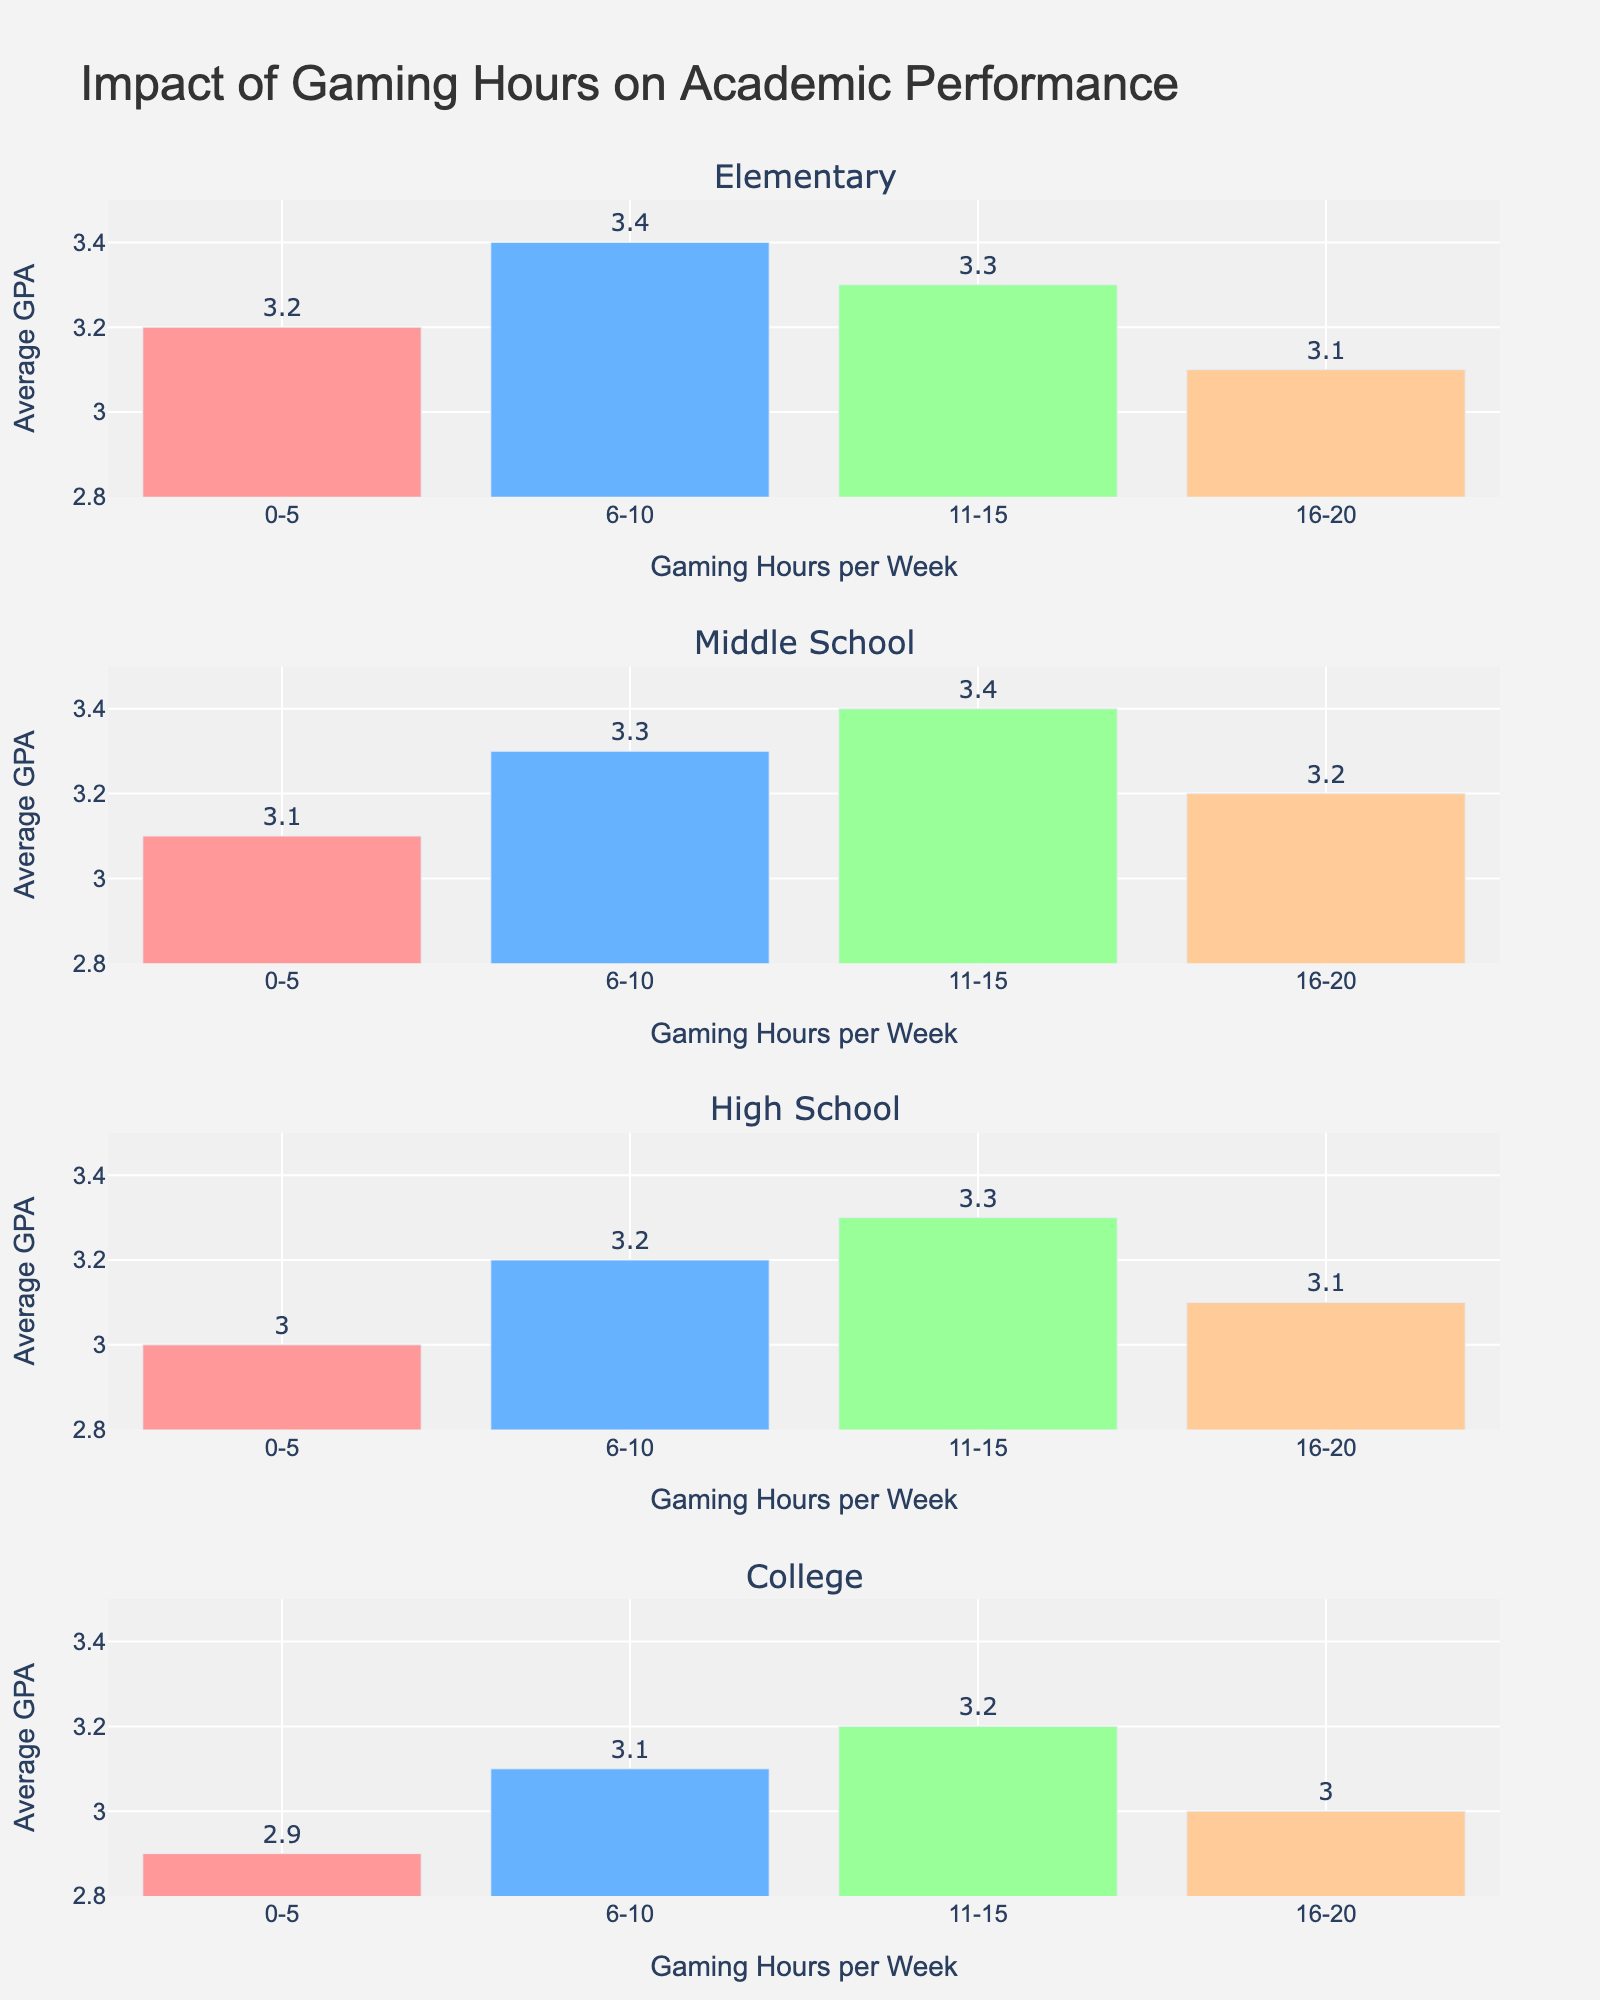What is the title of the plot? The title of the plot is clearly displayed at the top.
Answer: Impact of Gaming Hours on Academic Performance How does the average GPA for elementary students compare between those who game 0-5 hours and 6-10 hours per week? Look at the two bars for elementary students corresponding to 0-5 and 6-10 hours per week and compare their heights.
Answer: The average GPA is higher for those who game 6-10 hours Which grade level shows the highest average GPA for those who game 11-15 hours per week? Check the bars corresponding to 11-15 gaming hours across all grade levels and identify the highest one.
Answer: Middle School What is the color used for the bars representing 16-20 hours of gaming per week? Identify the color of the bars corresponding to 16-20 hours across all grade levels.
Answer: Peach Which grade level shows the most significant drop in average GPA when gaming hours increase from 11-15 to 16-20 per week? Compare the decreases in bar heights from 11-15 to 16-20 hours across all grade levels.
Answer: College What can be inferred about the relationship between gaming hours and GPA for elementary students? Examine the trend in the bar heights for elementary students from 0-5 to 16-20 hours per week.
Answer: GPA decreases slightly after 10 hours of gaming What is the maximum average GPA observed in the plot, and for which grade level and gaming hours does this occur? Identify the tallest bar in the entire plot and note its corresponding grade level and gaming hours.
Answer: 3.4 for Middle School, 11-15 hours Compare the average GPA of high school students who game 11-15 hours per week with that of college students who game the same amount. Locate and compare the bars for high school and college students at 11-15 hours of gaming.
Answer: High school students have a higher average GPA What is the range of the y-axis in the plot? The range of the y-axis can be observed by looking at the lowest and highest values marked on it.
Answer: 2.8 to 3.5 What is the average GPA for middle school students who game 6-10 hours per week? Locate the bar for middle school students gaming 6-10 hours and check its height or label.
Answer: 3.3 